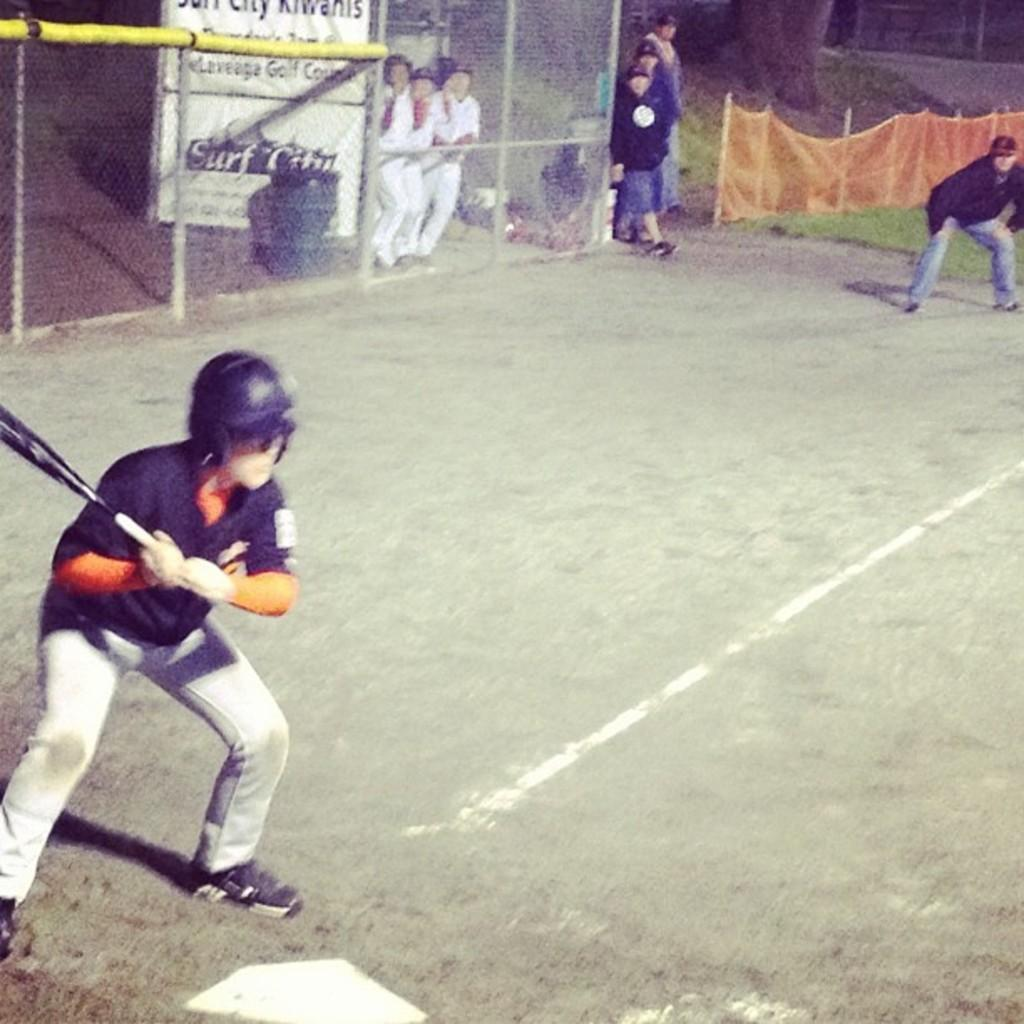Provide a one-sentence caption for the provided image. A baseball game takes place at a place called Surf City. 